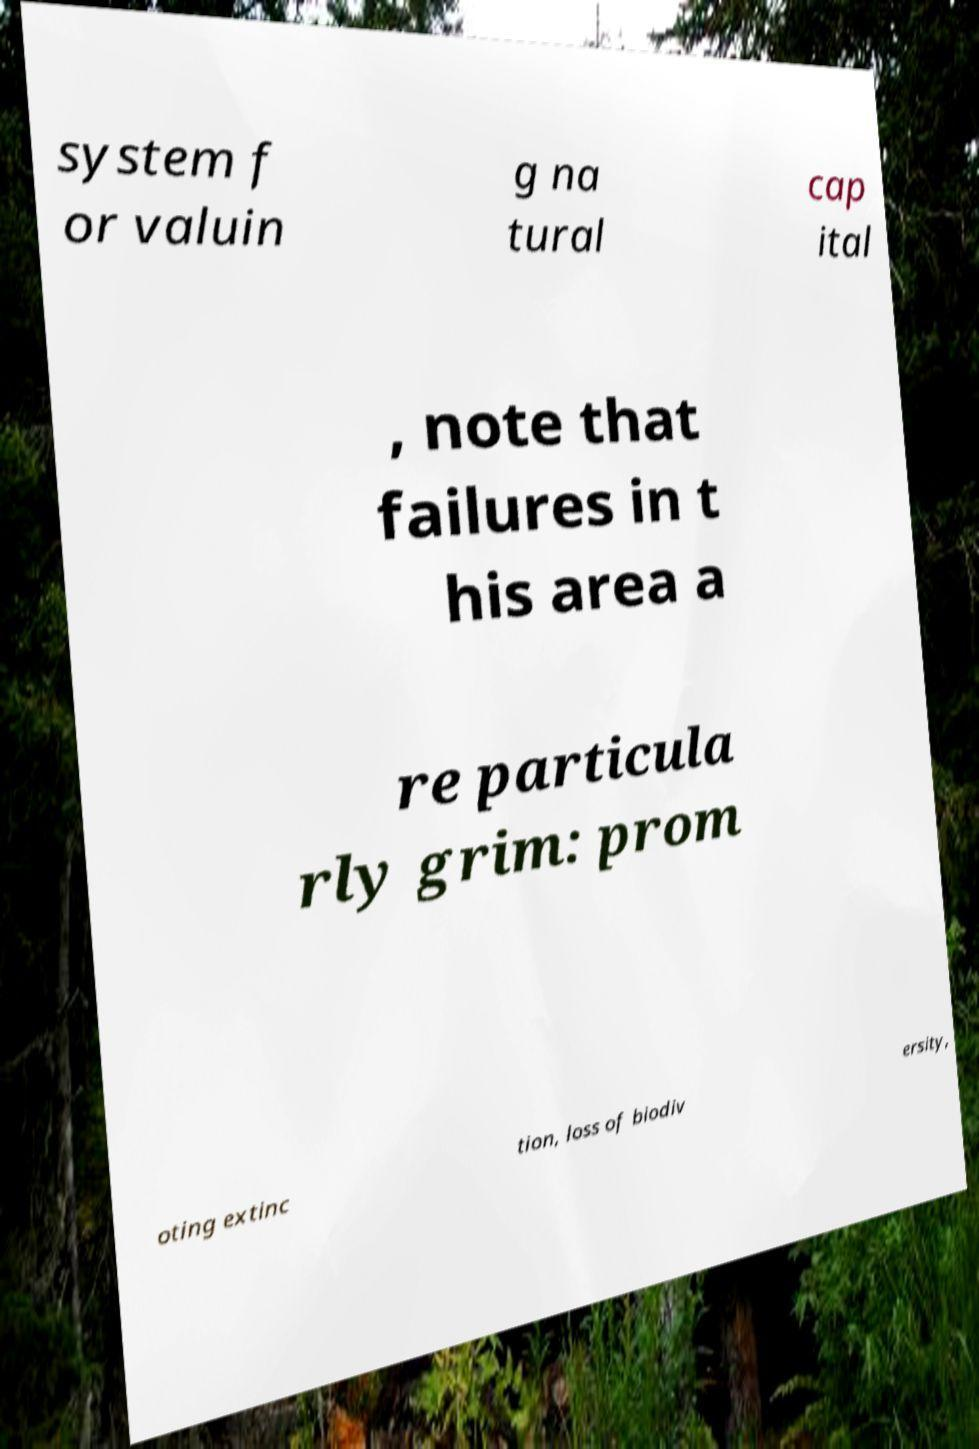What messages or text are displayed in this image? I need them in a readable, typed format. system f or valuin g na tural cap ital , note that failures in t his area a re particula rly grim: prom oting extinc tion, loss of biodiv ersity, 